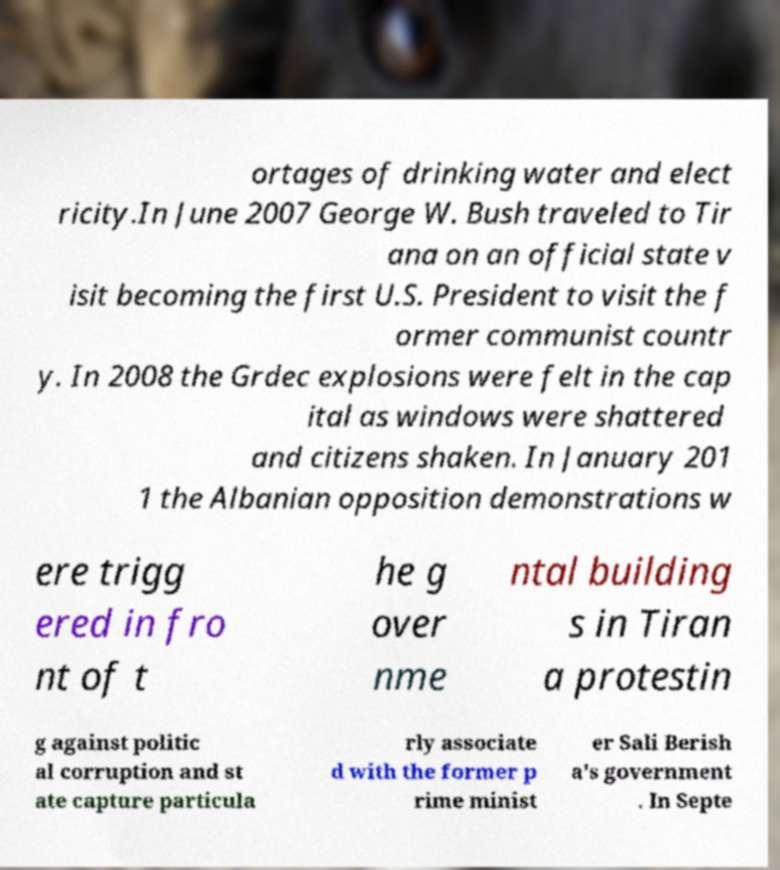There's text embedded in this image that I need extracted. Can you transcribe it verbatim? ortages of drinking water and elect ricity.In June 2007 George W. Bush traveled to Tir ana on an official state v isit becoming the first U.S. President to visit the f ormer communist countr y. In 2008 the Grdec explosions were felt in the cap ital as windows were shattered and citizens shaken. In January 201 1 the Albanian opposition demonstrations w ere trigg ered in fro nt of t he g over nme ntal building s in Tiran a protestin g against politic al corruption and st ate capture particula rly associate d with the former p rime minist er Sali Berish a's government . In Septe 